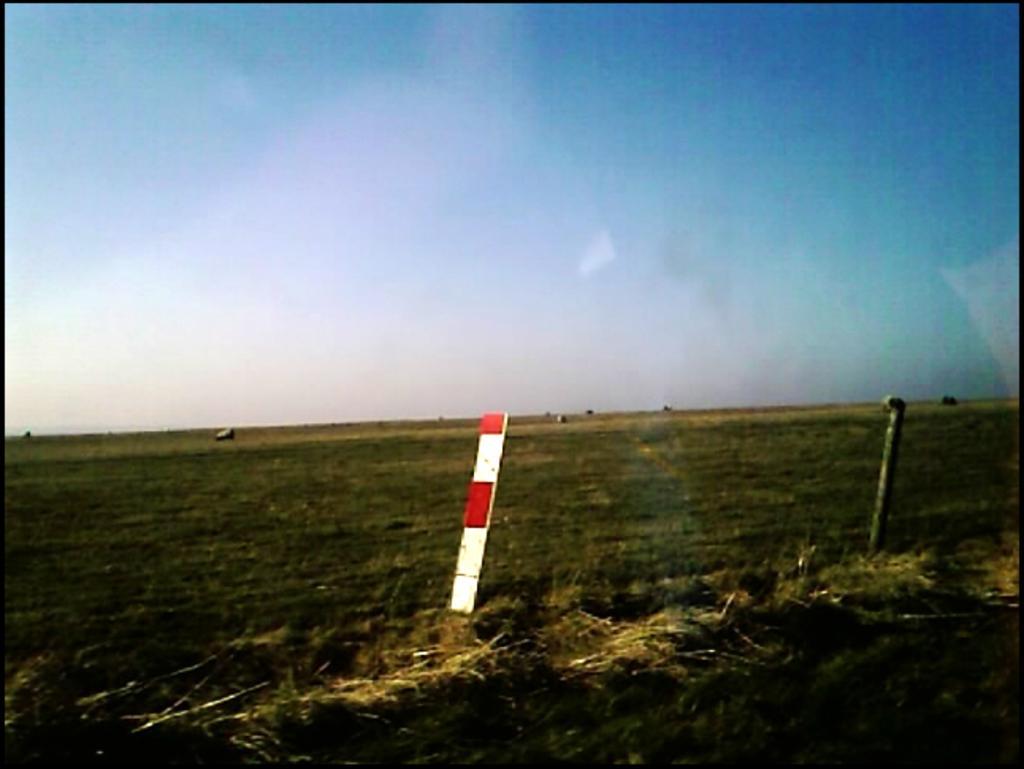Can you describe this image briefly? In this image I can see the ground, some grass on the ground, few poles and few other objects on the ground. In the background I can see the sky. 